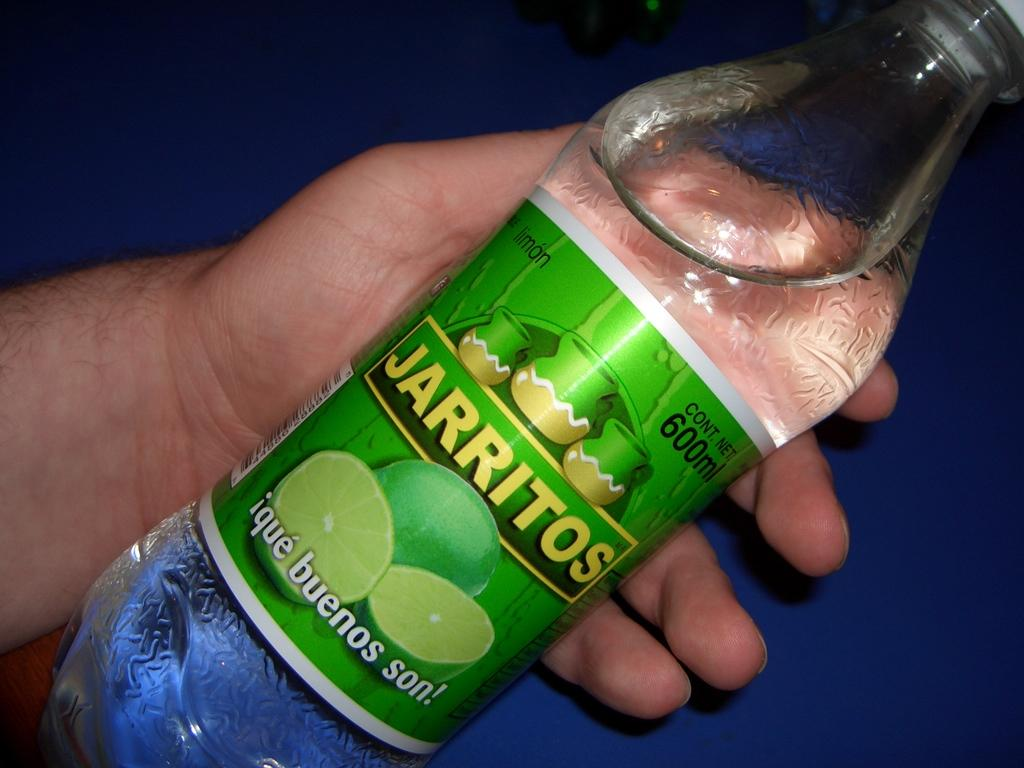What is the main subject of the image? There is a person in the image. What is the person holding in the image? The person is holding a water bottle. Can you describe the water bottle in more detail? The water bottle has a label and a lid. What type of seed can be seen growing on the bridge in the image? There is no bridge or seed present in the image. How does the person in the image express disgust? There is no indication of disgust in the image. 